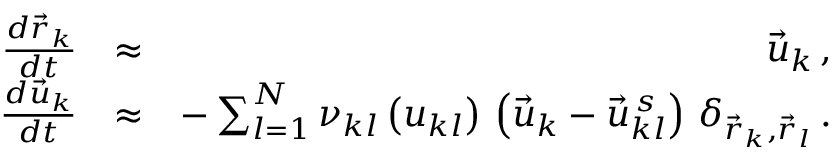Convert formula to latex. <formula><loc_0><loc_0><loc_500><loc_500>\begin{array} { r l r } { \frac { d \vec { r } _ { k } } { d t } } & { \approx } & { \vec { u } _ { k } \, , } \\ { \frac { d \vec { u } _ { k } } { d t } } & { \approx } & { - \sum _ { l = 1 } ^ { N } \nu _ { k l } \left ( u _ { k l } \right ) \, \left ( \vec { u } _ { k } - \vec { u } _ { k l } ^ { \, s } \right ) \, \delta _ { \vec { r } _ { k } , \vec { r } _ { l } } \, . } \end{array}</formula> 